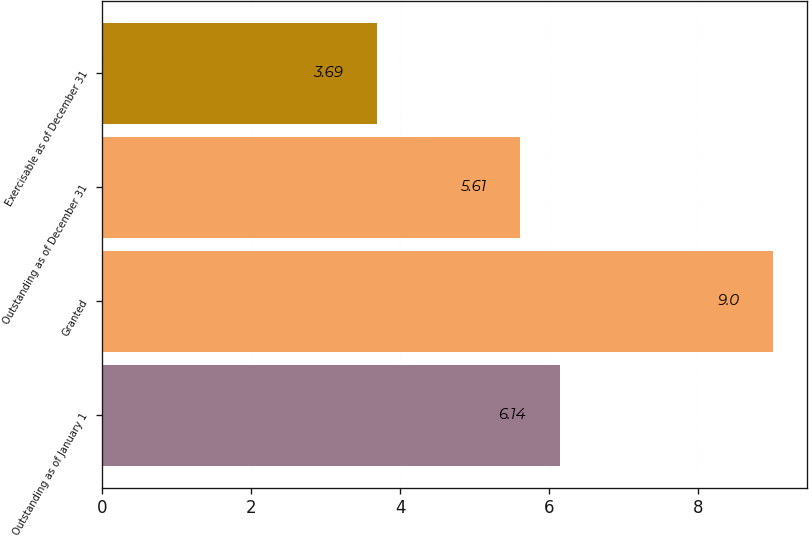<chart> <loc_0><loc_0><loc_500><loc_500><bar_chart><fcel>Outstanding as of January 1<fcel>Granted<fcel>Outstanding as of December 31<fcel>Exercisable as of December 31<nl><fcel>6.14<fcel>9<fcel>5.61<fcel>3.69<nl></chart> 